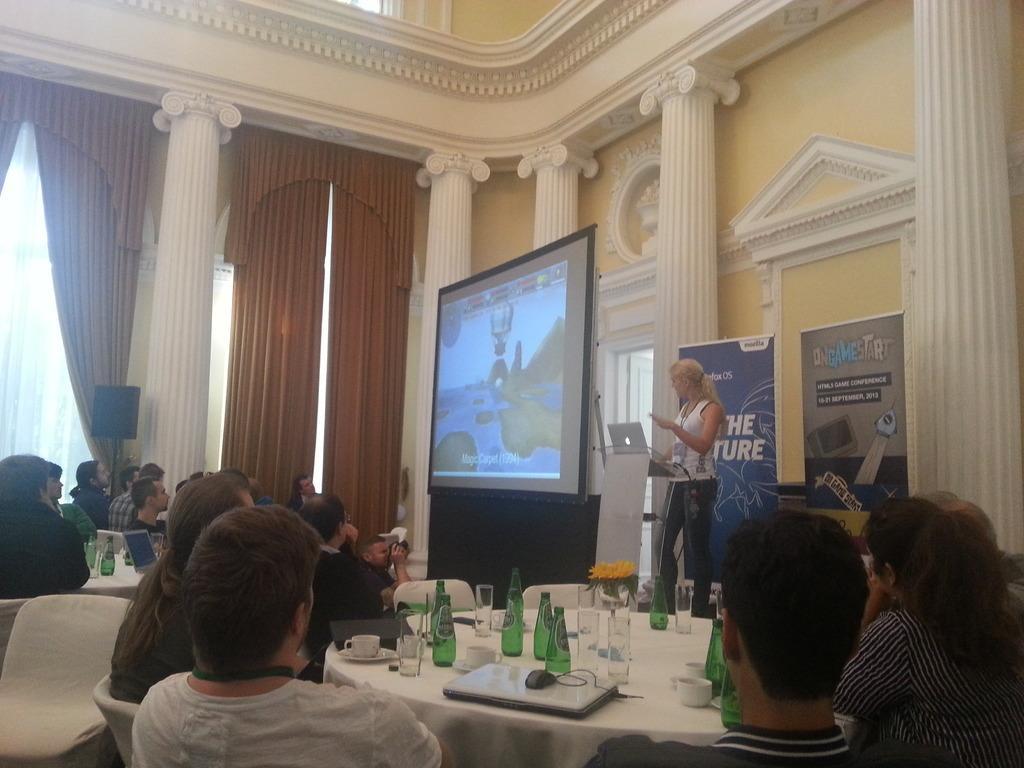Describe this image in one or two sentences. In this picture I can observe some people sitting on the chairs in front of the respective tables. I can observe bottles and glasses placed on the tables. In the middle of the picture I can observe screen. On the right side there is a woman standing in front of a podium. In the background I can observe pillars and curtains. 